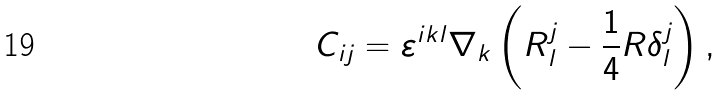Convert formula to latex. <formula><loc_0><loc_0><loc_500><loc_500>C _ { i j } = \varepsilon ^ { i k l } \nabla _ { k } \left ( R _ { l } ^ { j } - \frac { 1 } { 4 } R \delta _ { l } ^ { j } \right ) ,</formula> 